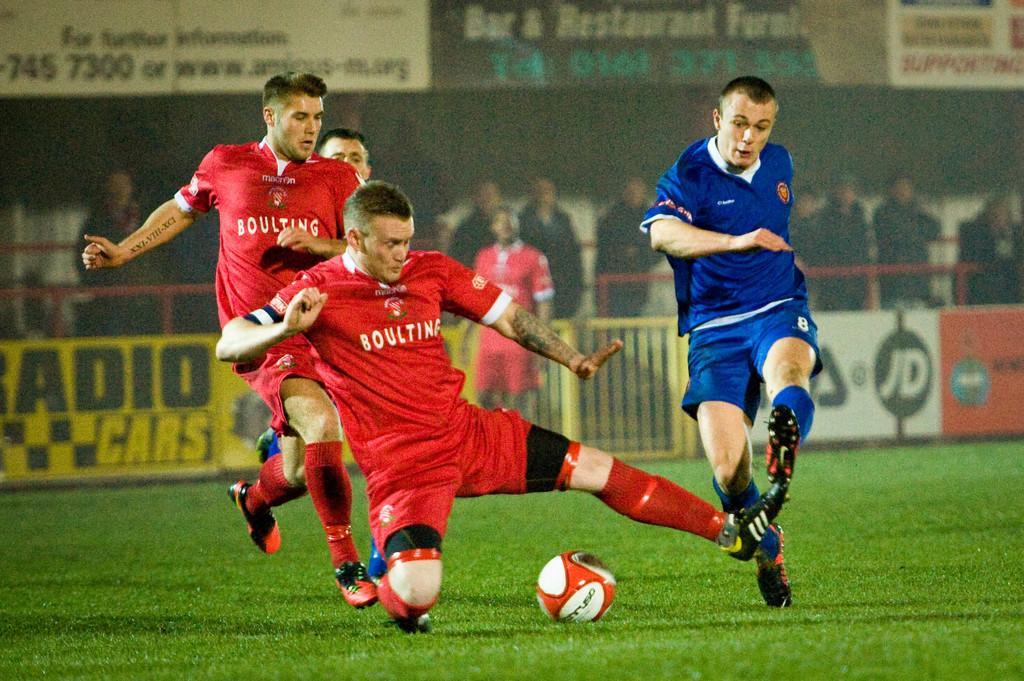Please provide a concise description of this image. In this image there are four men running on the ground. There is a football on the ground. There is grass on the ground. Behind them there is a railing. There are boards with text to the railing. Behind the railing there are people standing. At the top there are boards. 